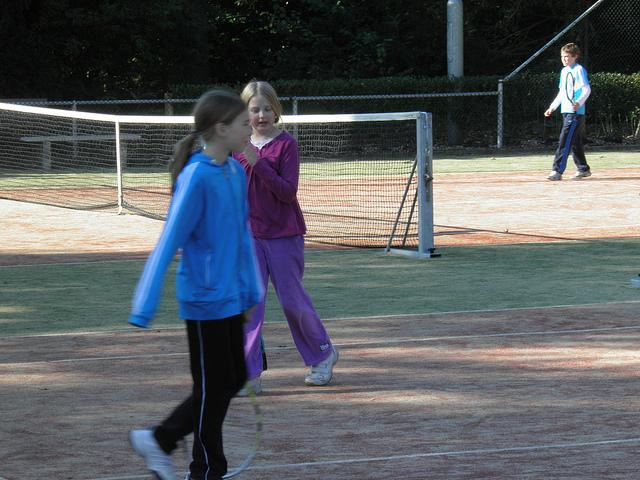What hair style does the girl in blue have? ponytail 